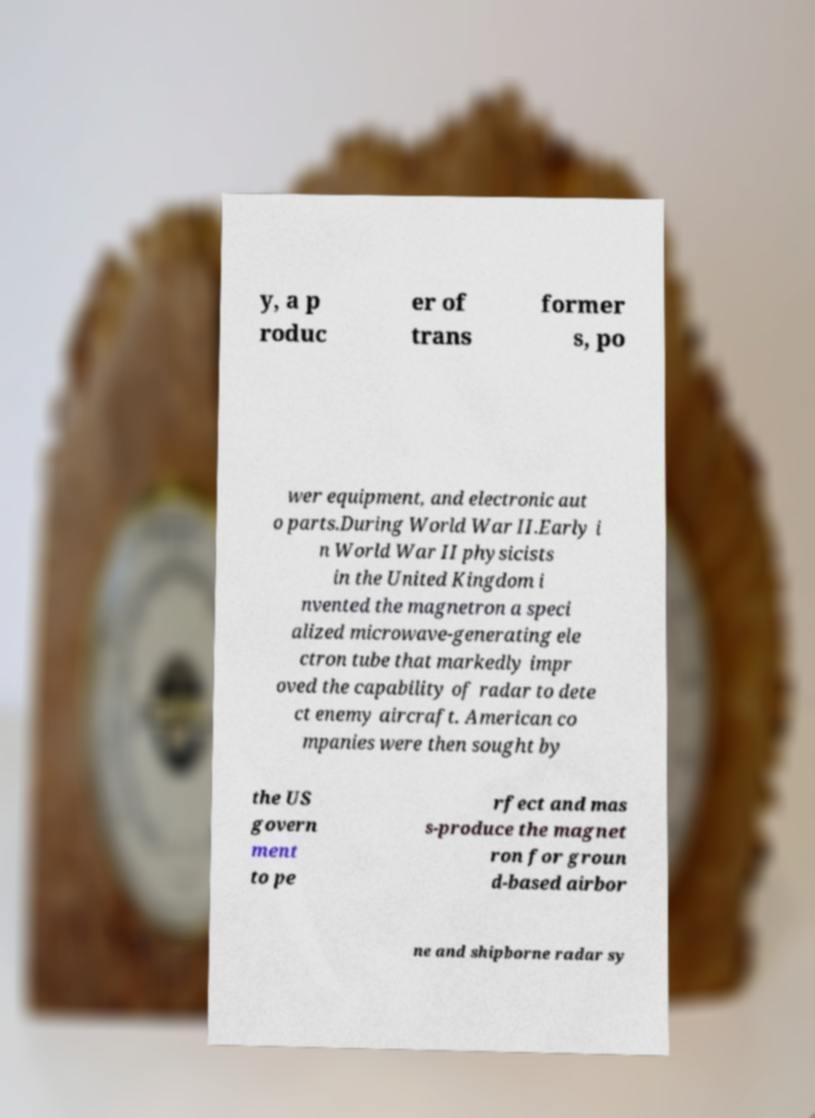Could you extract and type out the text from this image? y, a p roduc er of trans former s, po wer equipment, and electronic aut o parts.During World War II.Early i n World War II physicists in the United Kingdom i nvented the magnetron a speci alized microwave-generating ele ctron tube that markedly impr oved the capability of radar to dete ct enemy aircraft. American co mpanies were then sought by the US govern ment to pe rfect and mas s-produce the magnet ron for groun d-based airbor ne and shipborne radar sy 